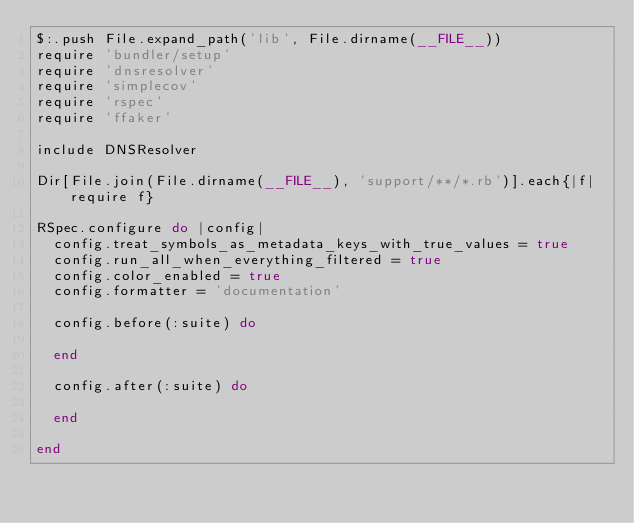Convert code to text. <code><loc_0><loc_0><loc_500><loc_500><_Ruby_>$:.push File.expand_path('lib', File.dirname(__FILE__))
require 'bundler/setup'
require 'dnsresolver'
require 'simplecov'
require 'rspec'
require 'ffaker'

include DNSResolver

Dir[File.join(File.dirname(__FILE__), 'support/**/*.rb')].each{|f| require f}

RSpec.configure do |config|
  config.treat_symbols_as_metadata_keys_with_true_values = true
  config.run_all_when_everything_filtered = true
  config.color_enabled = true
  config.formatter = 'documentation'

  config.before(:suite) do

  end

  config.after(:suite) do

  end

end</code> 